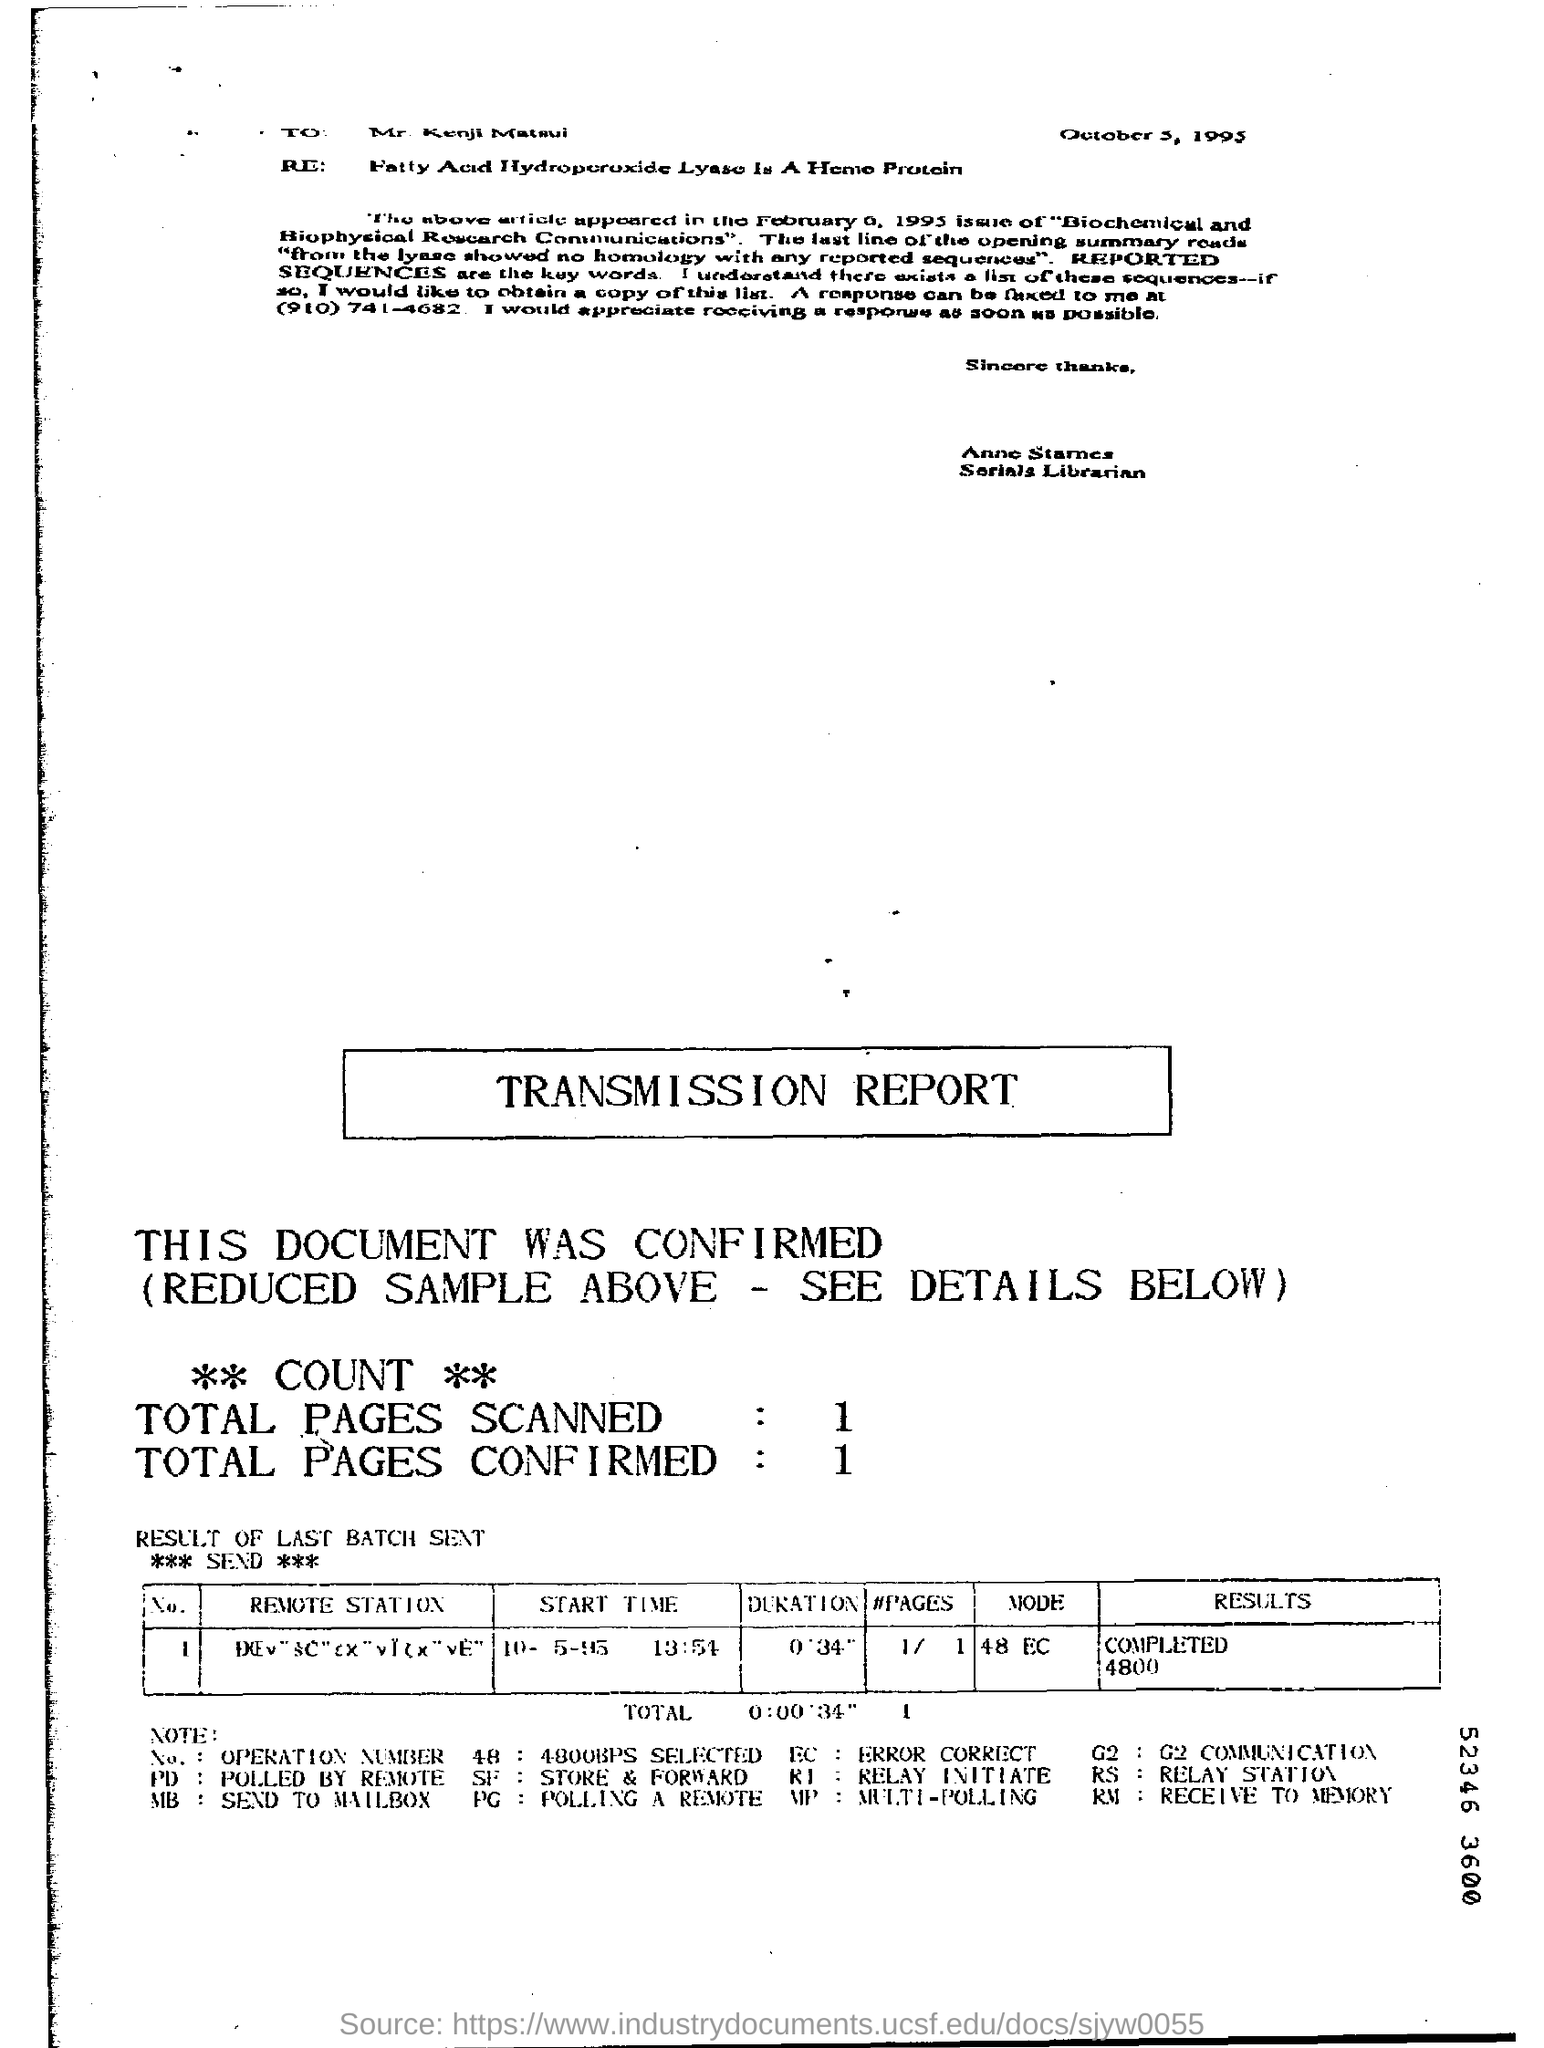On which date this letter was written ?
Your answer should be very brief. OCTOBER 5,1995. How many total pages are scanned in the transmission report ?
Ensure brevity in your answer.  1. How many total pages are confirmed in the report ?
Your answer should be compact. 1. What is the start time of the last batch ?
Your answer should be compact. 10-5-95  13:54. What is the time duration mentioned in the report ?
Keep it short and to the point. 0'34". What is the result in the report ?
Your answer should be compact. COMPLETED 4800. What is the mode given in the report ?
Your answer should be compact. 48 EC. 